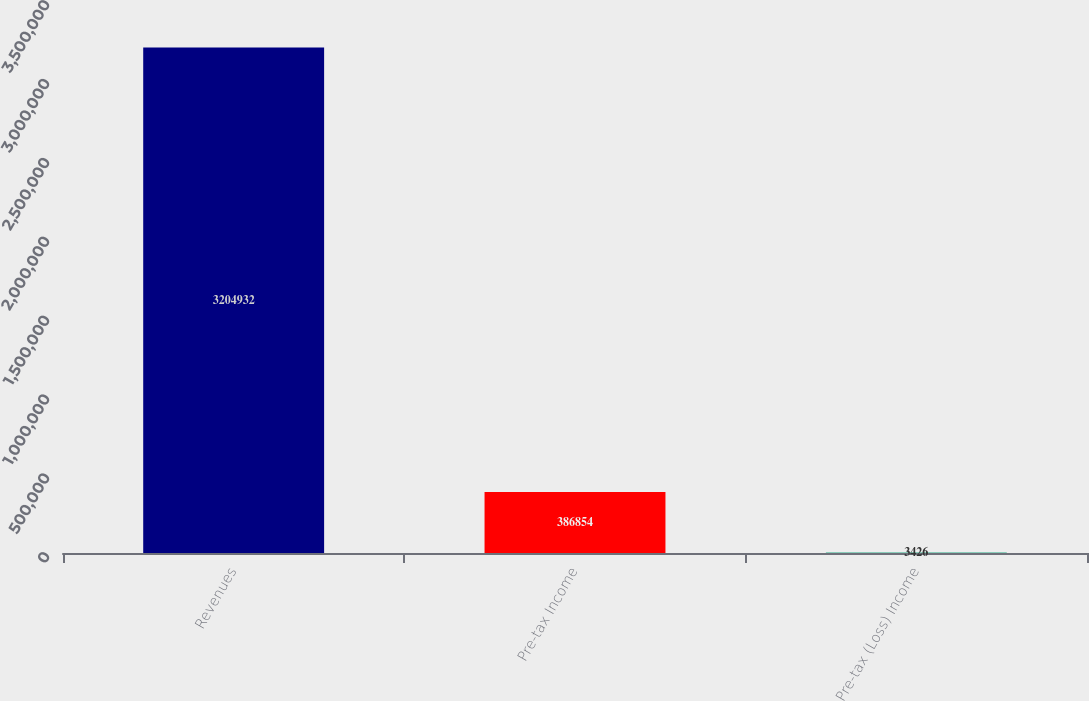Convert chart. <chart><loc_0><loc_0><loc_500><loc_500><bar_chart><fcel>Revenues<fcel>Pre-tax Income<fcel>Pre-tax (Loss) Income<nl><fcel>3.20493e+06<fcel>386854<fcel>3426<nl></chart> 